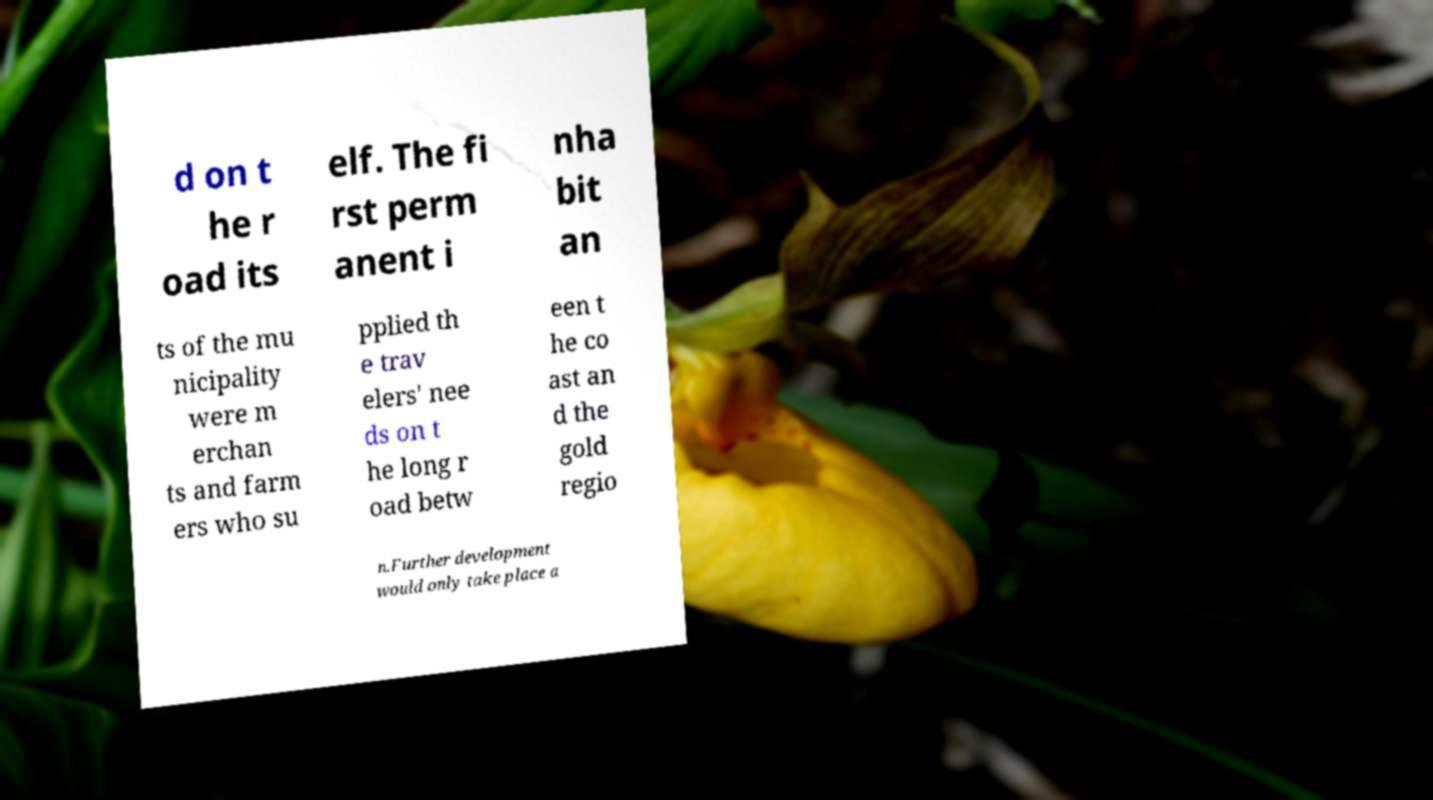Could you extract and type out the text from this image? d on t he r oad its elf. The fi rst perm anent i nha bit an ts of the mu nicipality were m erchan ts and farm ers who su pplied th e trav elers' nee ds on t he long r oad betw een t he co ast an d the gold regio n.Further development would only take place a 